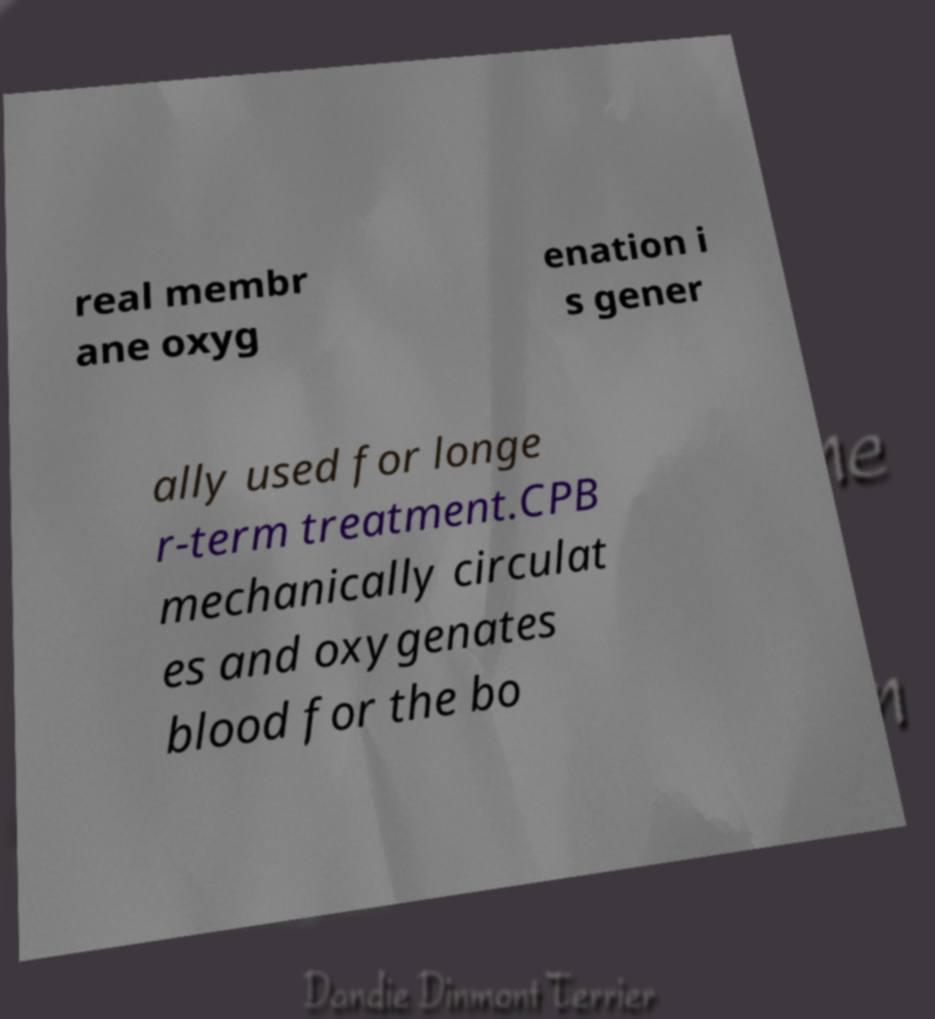Can you accurately transcribe the text from the provided image for me? real membr ane oxyg enation i s gener ally used for longe r-term treatment.CPB mechanically circulat es and oxygenates blood for the bo 